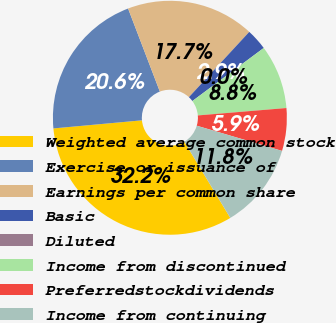Convert chart to OTSL. <chart><loc_0><loc_0><loc_500><loc_500><pie_chart><fcel>Weighted average common stock<fcel>Exercise or issuance of<fcel>Earnings per common share<fcel>Basic<fcel>Diluted<fcel>Income from discontinued<fcel>Preferredstockdividends<fcel>Income from continuing<nl><fcel>32.19%<fcel>20.64%<fcel>17.69%<fcel>2.95%<fcel>0.0%<fcel>8.85%<fcel>5.9%<fcel>11.79%<nl></chart> 